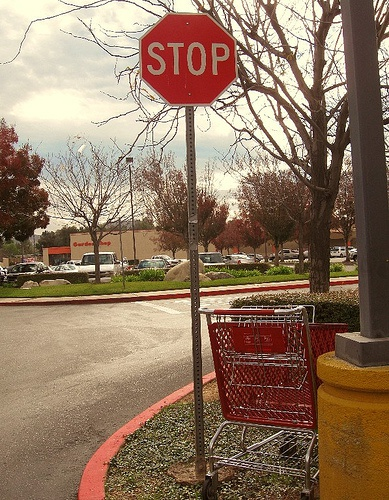Describe the objects in this image and their specific colors. I can see stop sign in lightyellow, brown, tan, and maroon tones, car in lightyellow, gray, beige, olive, and black tones, car in lightyellow, gray, darkgray, and tan tones, truck in lightyellow, black, maroon, and gray tones, and car in lightyellow, beige, darkgray, and gray tones in this image. 